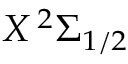<formula> <loc_0><loc_0><loc_500><loc_500>X \, ^ { 2 } \Sigma _ { 1 / 2 }</formula> 